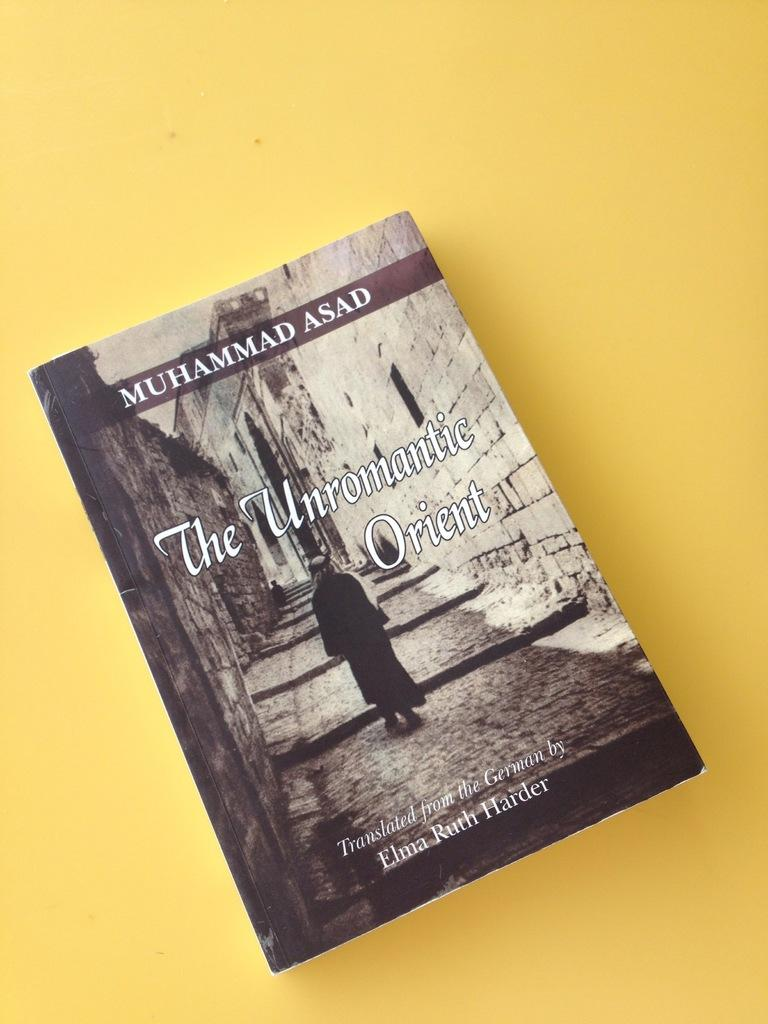<image>
Create a compact narrative representing the image presented. A black and white book cover is titled The Unromantic Orient. 